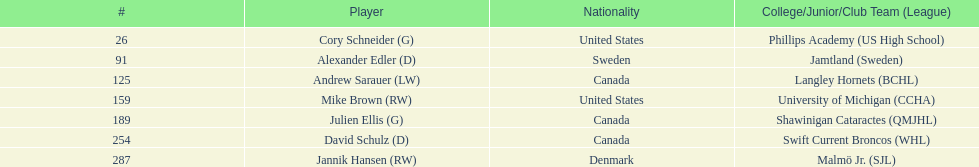How many canadian players are listed? 3. 